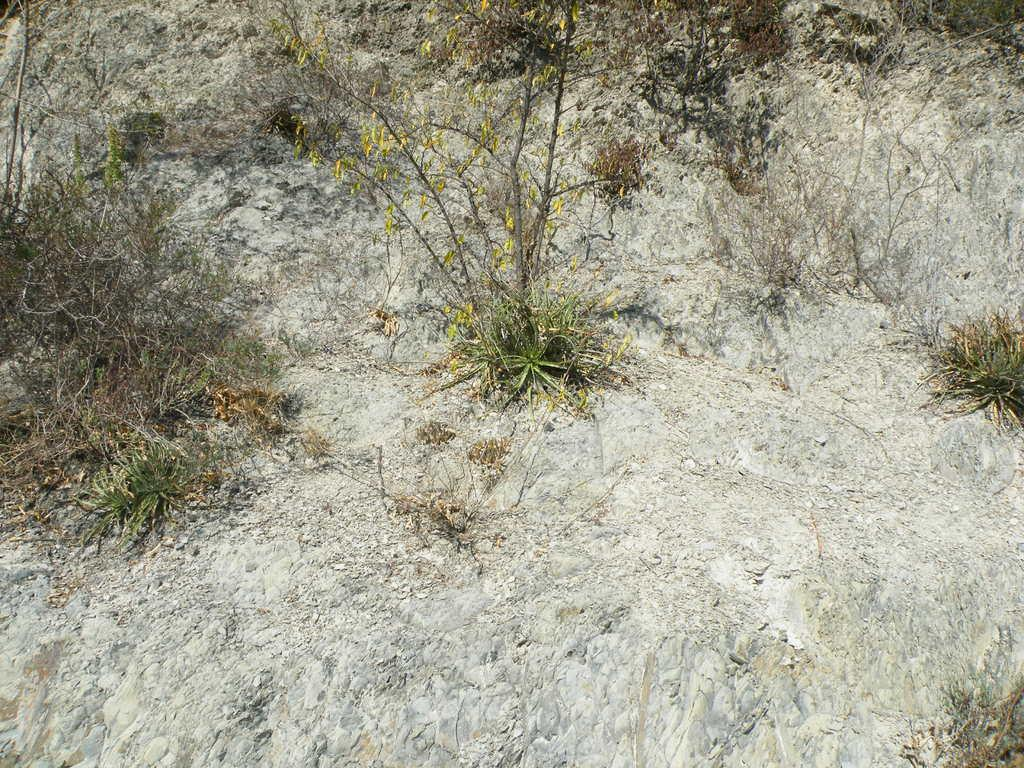What type of vegetation can be seen in the image? There are plants in the image. What is the condition of the grass in the image? There is dry grass in the image. On what surface are the plants and dry grass located? The plants and dry grass are on a surface. What type of humor can be found in the plants in the image? There is no humor present in the plants in the image; they are simply plants. 